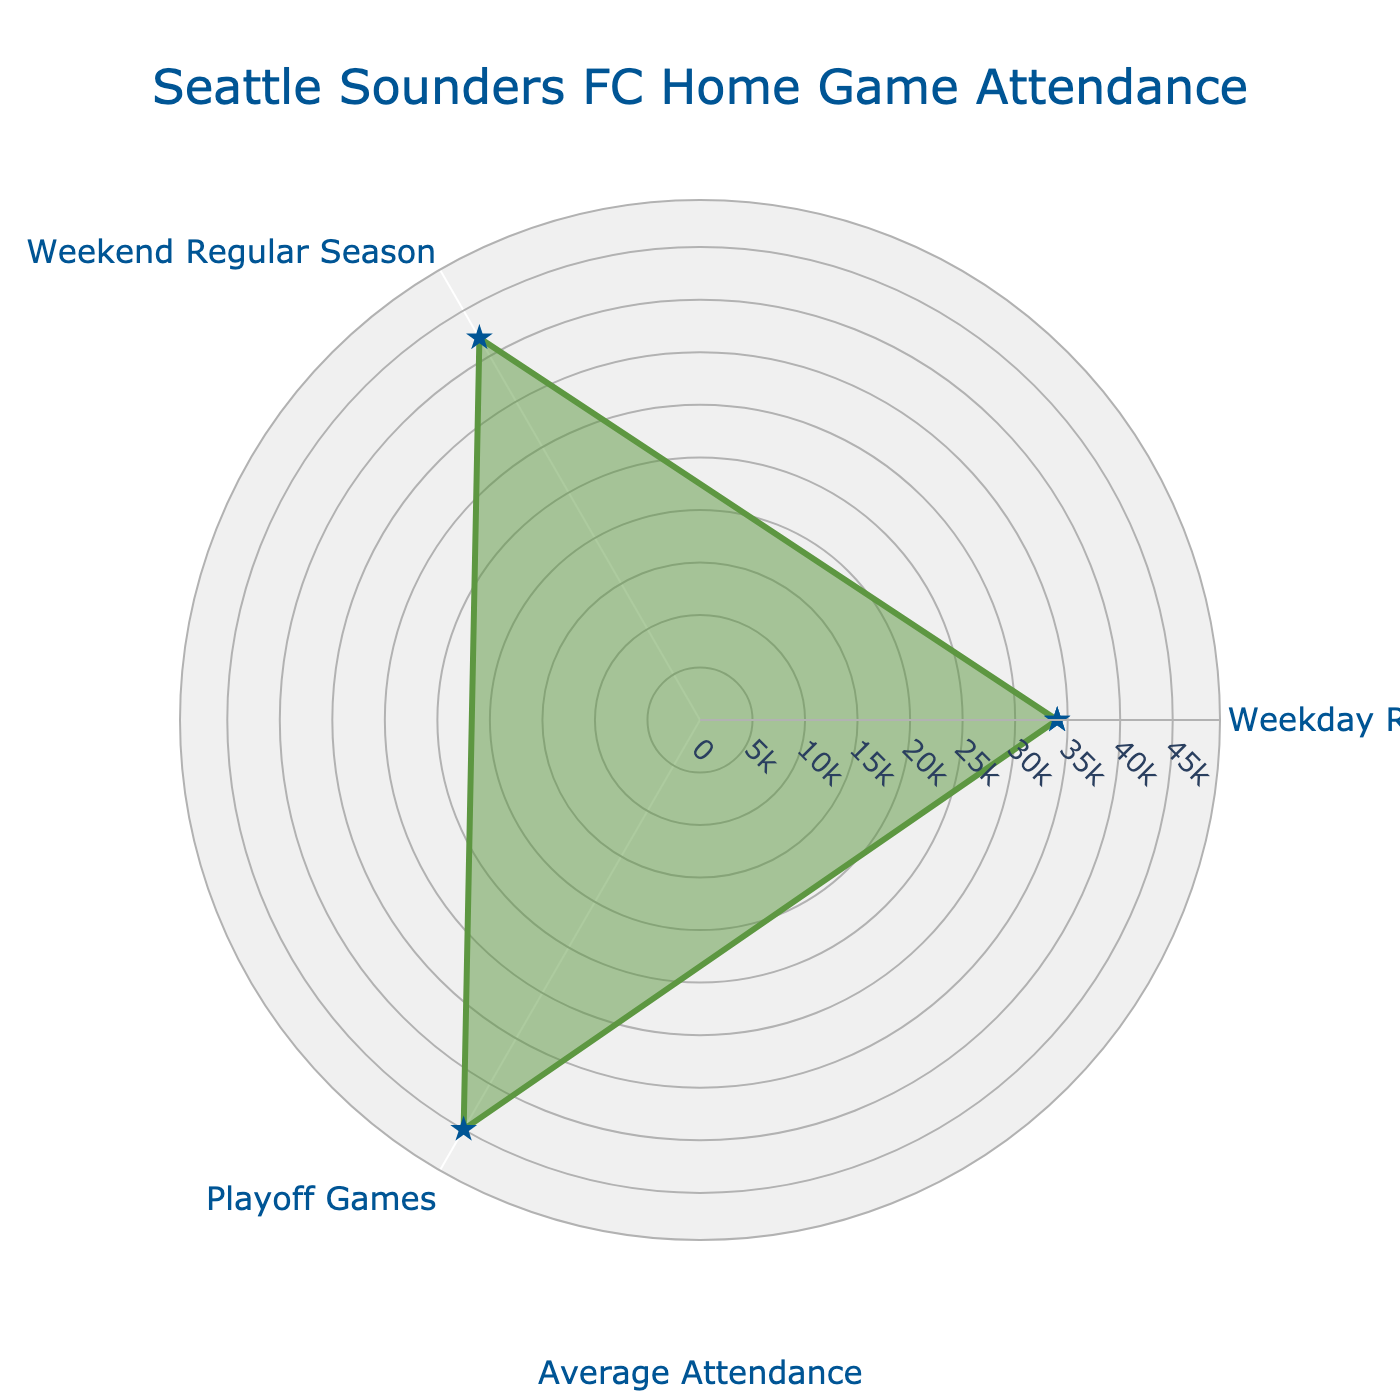Which game type has the highest average attendance? The radar chart highlights the average attendance for Weekday Regular Season, Weekend Regular Season, and Playoff Games. By observing the lengths of the radial lines, Playoff Games show the highest value.
Answer: Playoff Games What is the range of average attendances shown in the chart? The minimum average attendance is for Weekday Regular Season at 34,000, and the maximum is for Playoff Games at 45,000. Therefore, the range is 45,000 - 34,000.
Answer: 11,000 How does the attendance at Weekend Regular Season games compare to Weekday Regular Season games? By comparing the corresponding lengths of the radial lines, the Weekend Regular Season games have a longer radial line indicating a higher attendance of 42,000 compared to 34,000 for Weekday Regular Season games.
Answer: Higher What's the difference between the average attendance of Weekend Regular Season and Playoff Games? The Weekend Regular Season games have an average attendance of 42,000, whereas Playoff Games have 45,000. The difference is calculated as 45,000 - 42,000.
Answer: 3,000 How much higher is the attendance for Playoff Games compared to Weekday Regular Season games? The average attendance for Playoff Games is 45,000 and for Weekday Regular Season is 34,000. By subtracting the Weekday value from the Playoff value (45,000 - 34,000), we get the difference.
Answer: 11,000 Which game type has the lowest average attendance? The radar chart has the shortest radial line for Weekday Regular Season games, indicating the lowest attendance.
Answer: Weekday Regular Season What percentage increase in attendance does the Weekday Regular Season show compared to the Weekend Regular Season? The attendance for the Weekend Regular Season (42,000) and Weekday Regular Season (34,000). The percentage increase is calculated as ((42,000 - 34,000) / 34,000) * 100.
Answer: 23.53% If the Playoff Games attendance is set as a baseline (100%), what percentage of this baseline do Weekend Regular Season games represent? The Playoff Games average attendance is 45,000. Weekend Regular Season attendance is 42,000, so the percentage is calculated as (42,000 / 45,000) * 100.
Answer: 93.33% How do the attendances for the three game types relate to each other in a rank order? By comparing the lengths of the radar chart's radial lines, the ranking from highest to lowest attendance is: Playoff Games, Weekend Regular Season, Weekday Regular Season.
Answer: Playoff > Weekend Regular > Weekday Regular 